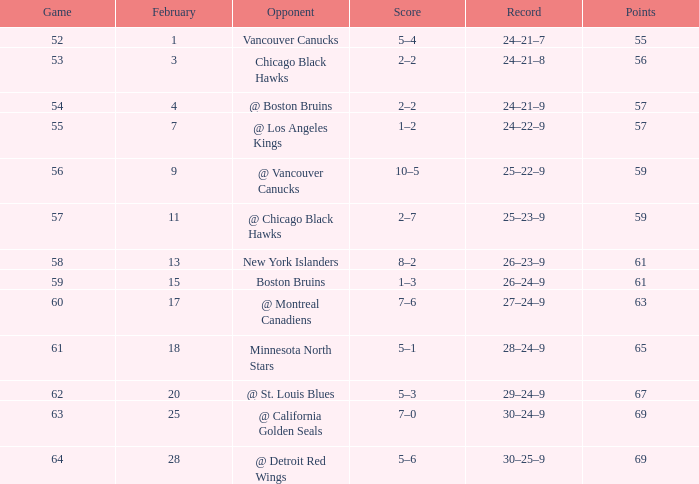Which competitor has a game surpassing 61, february under 28, and a point tally fewer than 69? @ St. Louis Blues. 